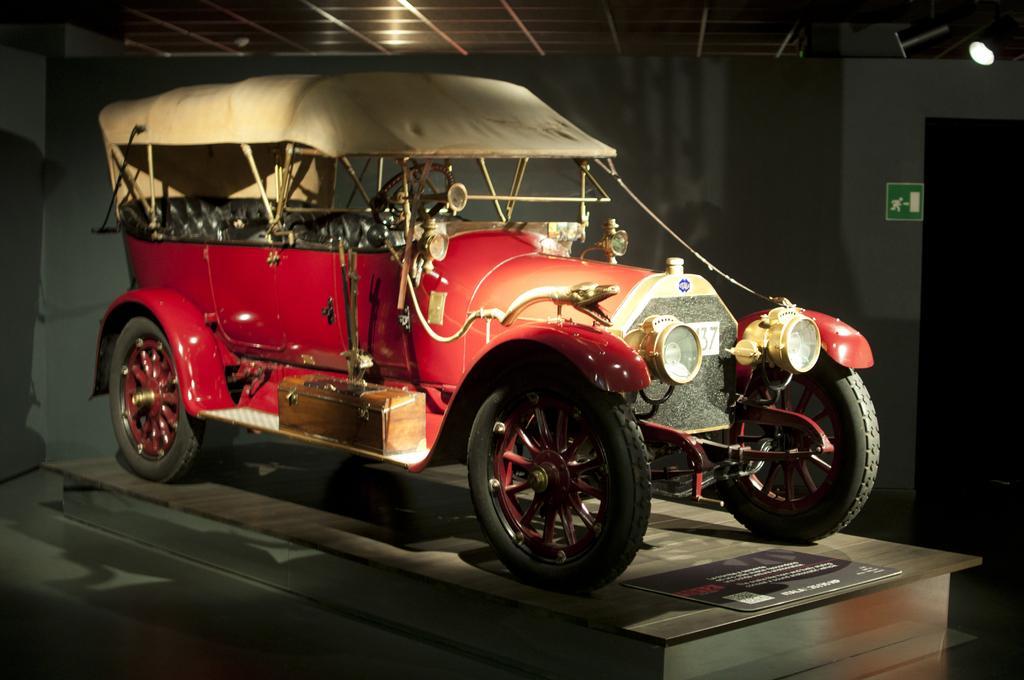Could you give a brief overview of what you see in this image? In this image in the center there is one vehicle, at the bottom there is floor and some board. On the board there is some text, and in the background there is a wall. At the top there is ceiling, and on the right side there is one light and a door. 